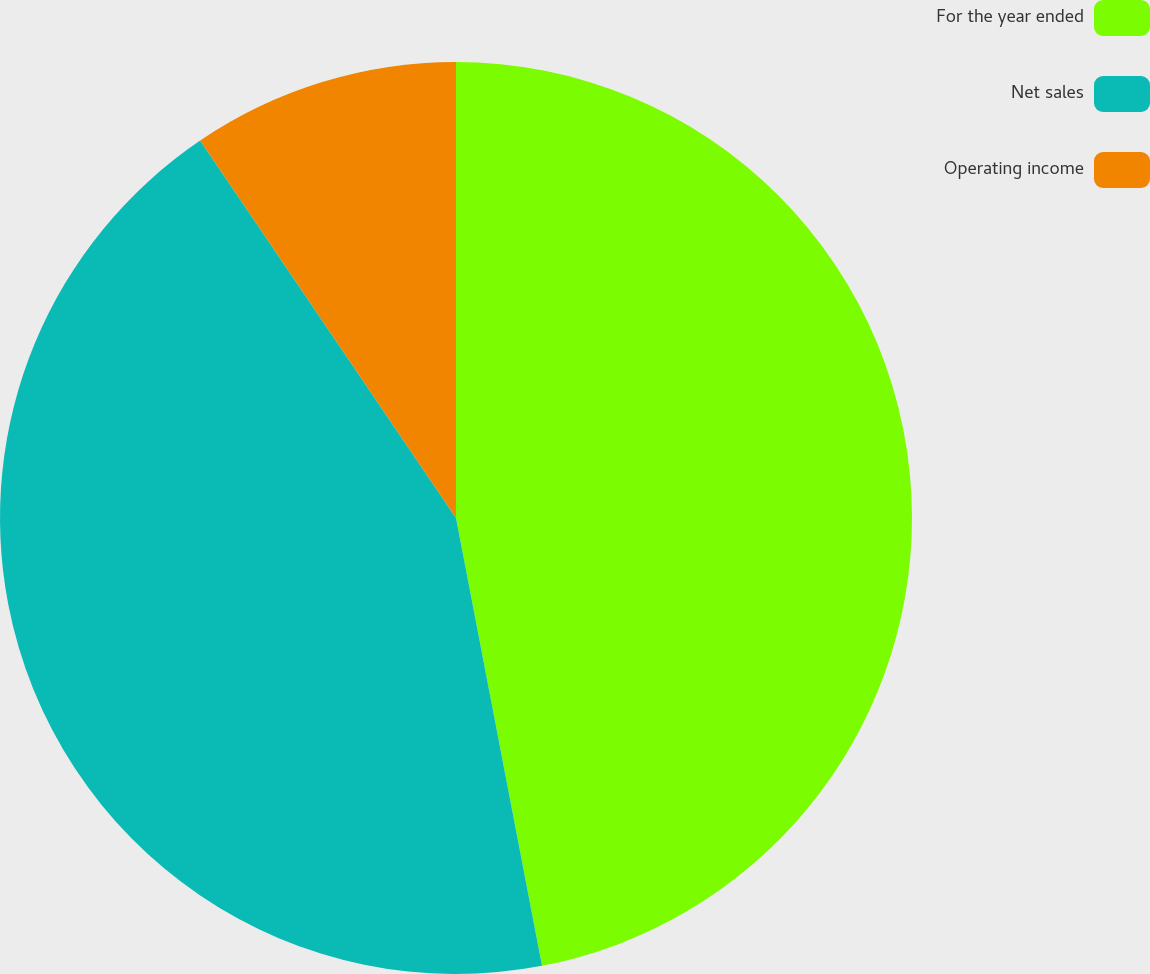Convert chart to OTSL. <chart><loc_0><loc_0><loc_500><loc_500><pie_chart><fcel>For the year ended<fcel>Net sales<fcel>Operating income<nl><fcel>46.98%<fcel>43.54%<fcel>9.48%<nl></chart> 